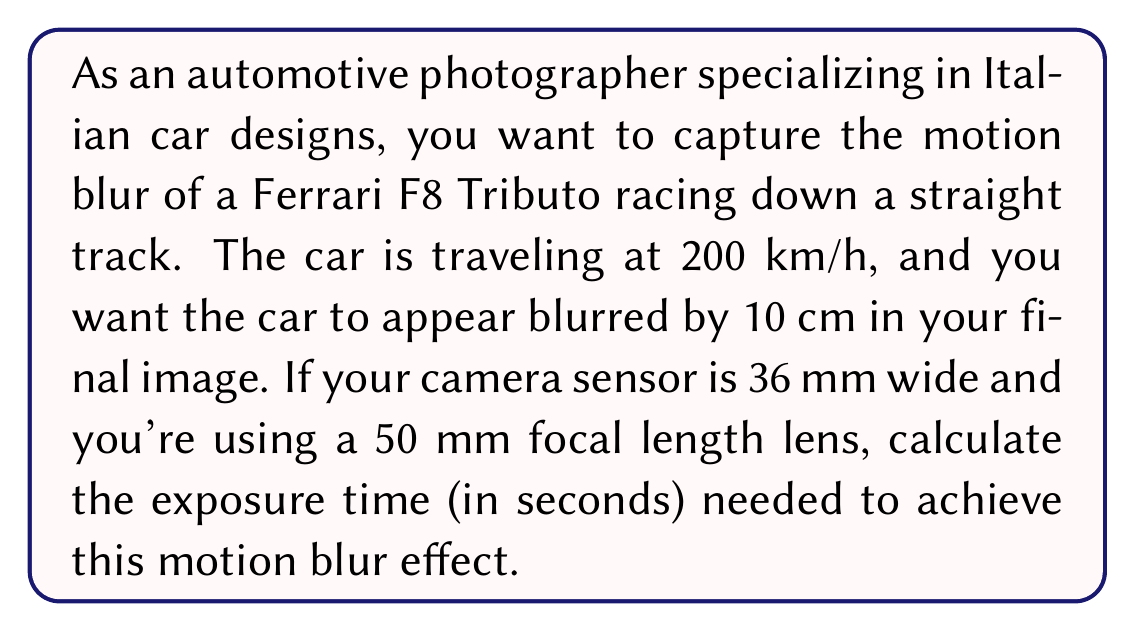Can you answer this question? To solve this problem, we need to follow these steps:

1. Convert the car's speed from km/h to m/s:
   $$ 200 \frac{km}{h} \times \frac{1000 m}{1 km} \times \frac{1 h}{3600 s} = \frac{500}{9} \approx 55.56 \frac{m}{s} $$

2. Calculate the magnification factor of the image:
   Magnification = (Sensor width) / (Focal length)
   $$ M = \frac{36 mm}{50 mm} = 0.72 $$

3. Calculate the actual distance the car needs to travel to appear blurred by 10 cm in the image:
   $$ \text{Actual distance} = \frac{\text{Desired blur in image}}{\text{Magnification}} = \frac{10 cm}{0.72} \approx 13.89 cm $$

4. Use the formula: Time = Distance / Speed
   $$ t = \frac{d}{v} = \frac{13.89 cm}{55.56 \frac{m}{s}} $$

5. Convert cm to m:
   $$ t = \frac{0.1389 m}{55.56 \frac{m}{s}} = \frac{0.1389}{55.56} s \approx 0.0025 s $$

Thus, the required exposure time is approximately 0.0025 seconds or 1/400th of a second.
Answer: The exposure time needed to capture a 10 cm motion blur of a Ferrari F8 Tributo traveling at 200 km/h is approximately 0.0025 seconds or 1/400th of a second. 